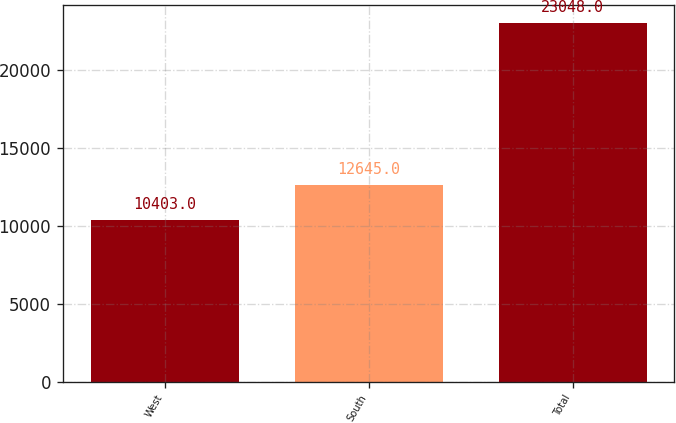<chart> <loc_0><loc_0><loc_500><loc_500><bar_chart><fcel>West<fcel>South<fcel>Total<nl><fcel>10403<fcel>12645<fcel>23048<nl></chart> 